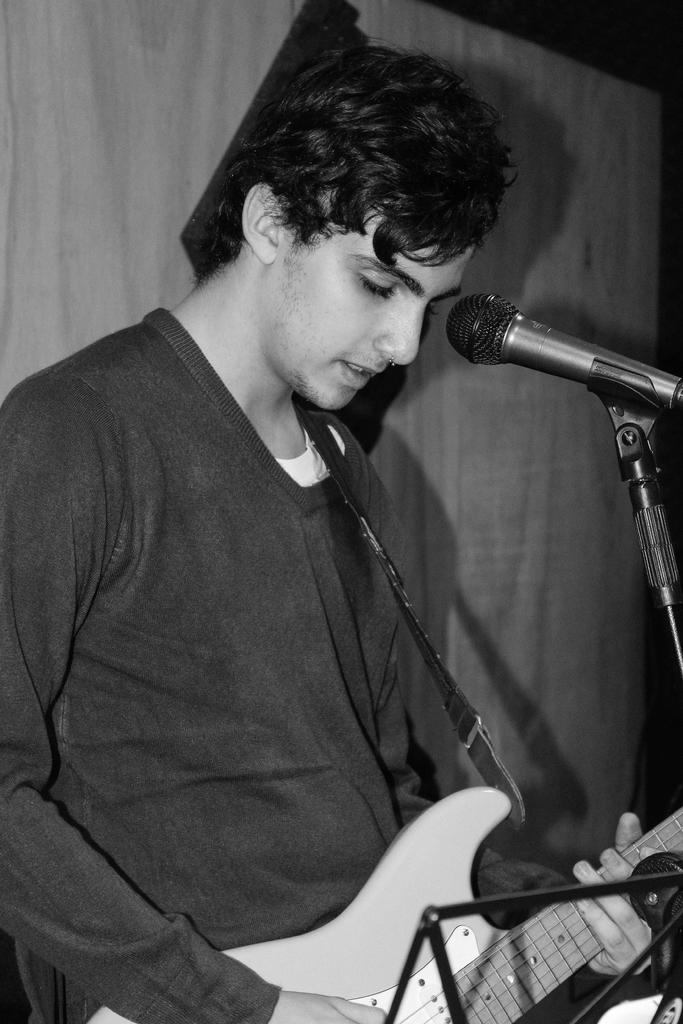Who is the main subject in the image? There is a man in the center of the image. What is the man doing in the image? The man is playing a guitar. What object is in front of the man? There is a microphone in front of the man. What can be seen in the background of the image? There is a wall in the background of the image. Where is the woman playing the game with her dad in the image? There is no woman or game with a dad present in the image; it features a man playing a guitar with a microphone in front of him. 